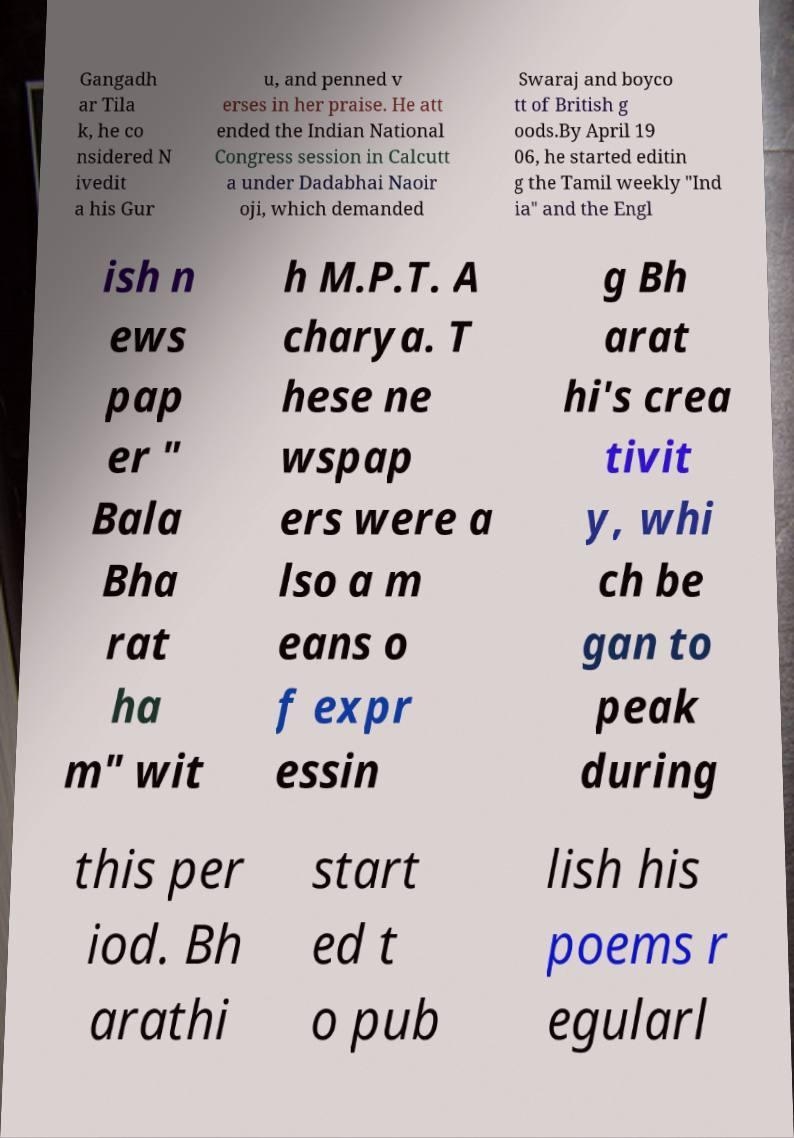There's text embedded in this image that I need extracted. Can you transcribe it verbatim? Gangadh ar Tila k, he co nsidered N ivedit a his Gur u, and penned v erses in her praise. He att ended the Indian National Congress session in Calcutt a under Dadabhai Naoir oji, which demanded Swaraj and boyco tt of British g oods.By April 19 06, he started editin g the Tamil weekly "Ind ia" and the Engl ish n ews pap er " Bala Bha rat ha m" wit h M.P.T. A charya. T hese ne wspap ers were a lso a m eans o f expr essin g Bh arat hi's crea tivit y, whi ch be gan to peak during this per iod. Bh arathi start ed t o pub lish his poems r egularl 